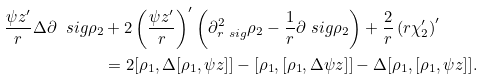<formula> <loc_0><loc_0><loc_500><loc_500>\frac { \psi _ { \L } z ^ { \prime } } { r } \Delta \partial _ { \ } s i g \rho _ { 2 } & + 2 \left ( \frac { \psi _ { \L } z ^ { \prime } } { r } \right ) ^ { \prime } \left ( \partial ^ { 2 } _ { r \ s i g } \rho _ { 2 } - \frac { 1 } { r } \partial _ { \ } s i g \rho _ { 2 } \right ) + \frac { 2 } { r } \left ( r \chi _ { 2 } ^ { \prime } \right ) ^ { \prime } \\ & = 2 [ \rho _ { 1 } , \Delta [ \rho _ { 1 } , \psi _ { \L } z ] ] - [ \rho _ { 1 } , [ \rho _ { 1 } , \Delta \psi _ { \L } z ] ] - \Delta [ \rho _ { 1 } , [ \rho _ { 1 } , \psi _ { \L } z ] ] .</formula> 